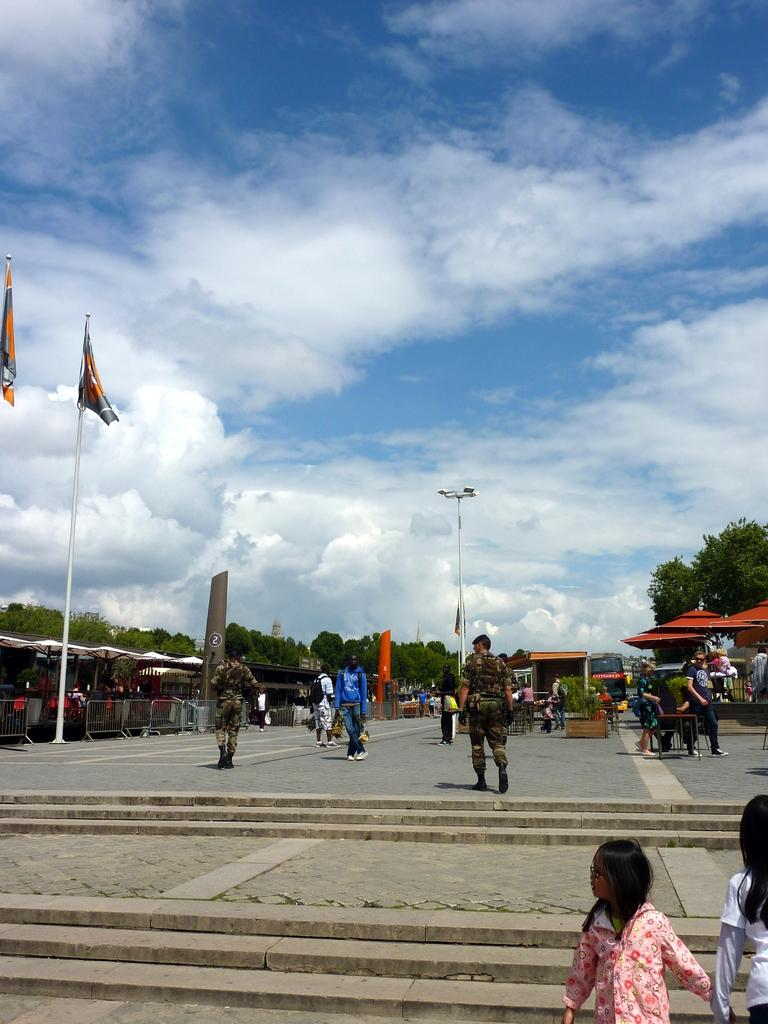How many people are in the image? There are people in the image, but the exact number cannot be determined from the provided facts. What can be seen in the image besides the people? There are steps, a road, poles, flags, banners, railings, trees, sheds, plants, and other objects visible in the image. What is the background of the image? The sky is visible in the background of the image, with clouds present. What type of error can be seen in the cheese in the image? There is no cheese present in the image, and therefore no errors can be observed. What statement is being made by the plants in the image? The plants in the image are not making any statements; they are simply plants. 